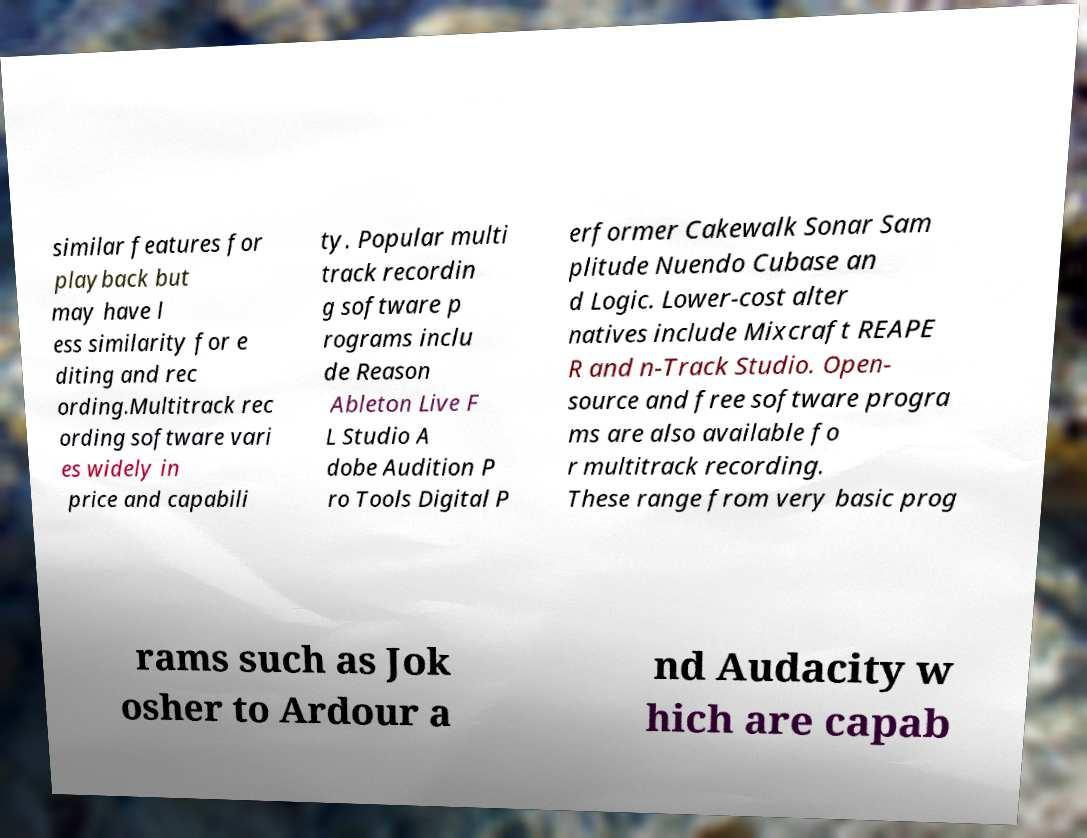There's text embedded in this image that I need extracted. Can you transcribe it verbatim? similar features for playback but may have l ess similarity for e diting and rec ording.Multitrack rec ording software vari es widely in price and capabili ty. Popular multi track recordin g software p rograms inclu de Reason Ableton Live F L Studio A dobe Audition P ro Tools Digital P erformer Cakewalk Sonar Sam plitude Nuendo Cubase an d Logic. Lower-cost alter natives include Mixcraft REAPE R and n-Track Studio. Open- source and free software progra ms are also available fo r multitrack recording. These range from very basic prog rams such as Jok osher to Ardour a nd Audacity w hich are capab 